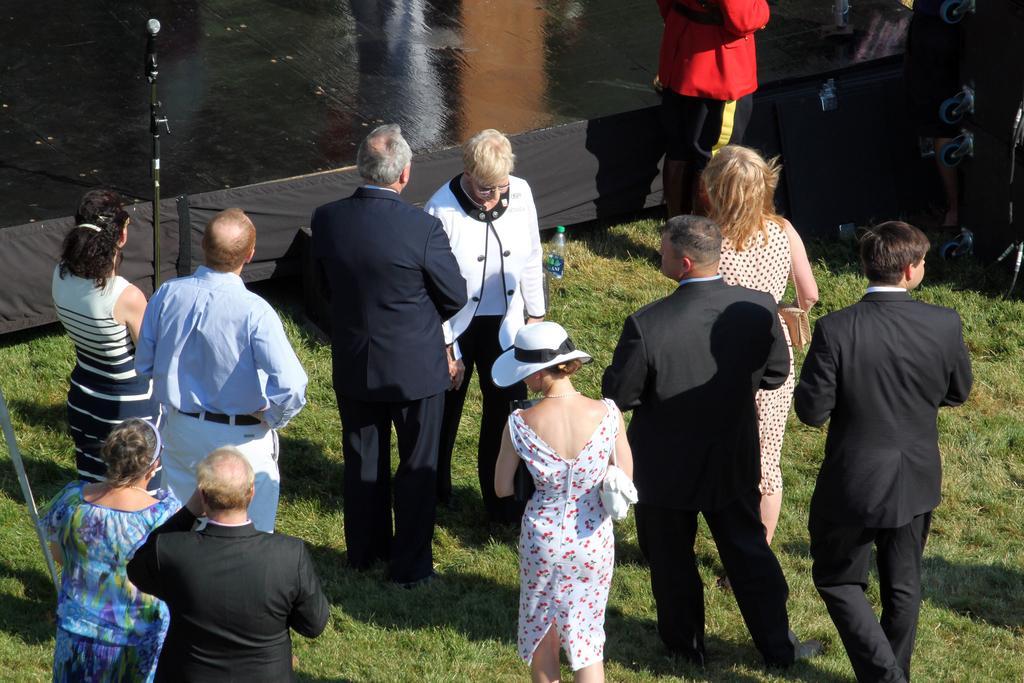Describe this image in one or two sentences. In this picture we can see people on the ground, here we can see a bottle, mic with a stand, grass and some objects and in the background we can see a fence, floor. 